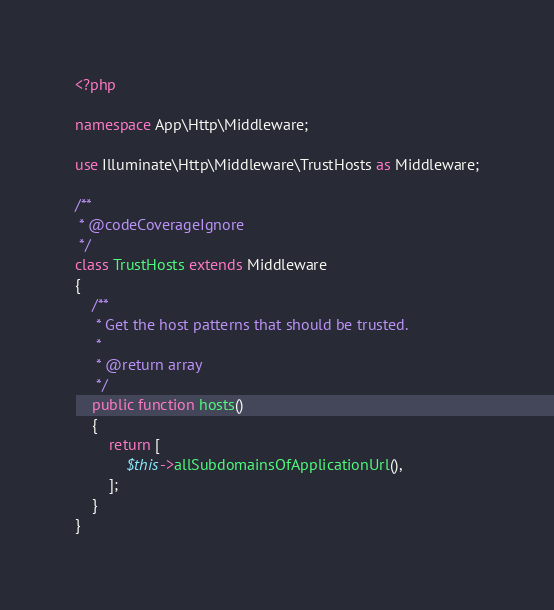<code> <loc_0><loc_0><loc_500><loc_500><_PHP_><?php

namespace App\Http\Middleware;

use Illuminate\Http\Middleware\TrustHosts as Middleware;

/**
 * @codeCoverageIgnore
 */
class TrustHosts extends Middleware
{
    /**
     * Get the host patterns that should be trusted.
     *
     * @return array
     */
    public function hosts()
    {
        return [
            $this->allSubdomainsOfApplicationUrl(),
        ];
    }
}
</code> 